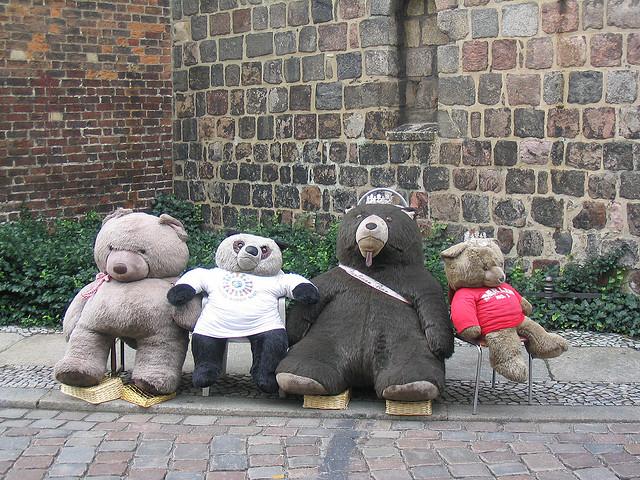What does the large dark teddy bear represent?
Be succinct. King. How many of the teddy bears are wearing clothing?
Be succinct. 2. How many bears?
Answer briefly. 4. How many bears are there?
Concise answer only. 4. 